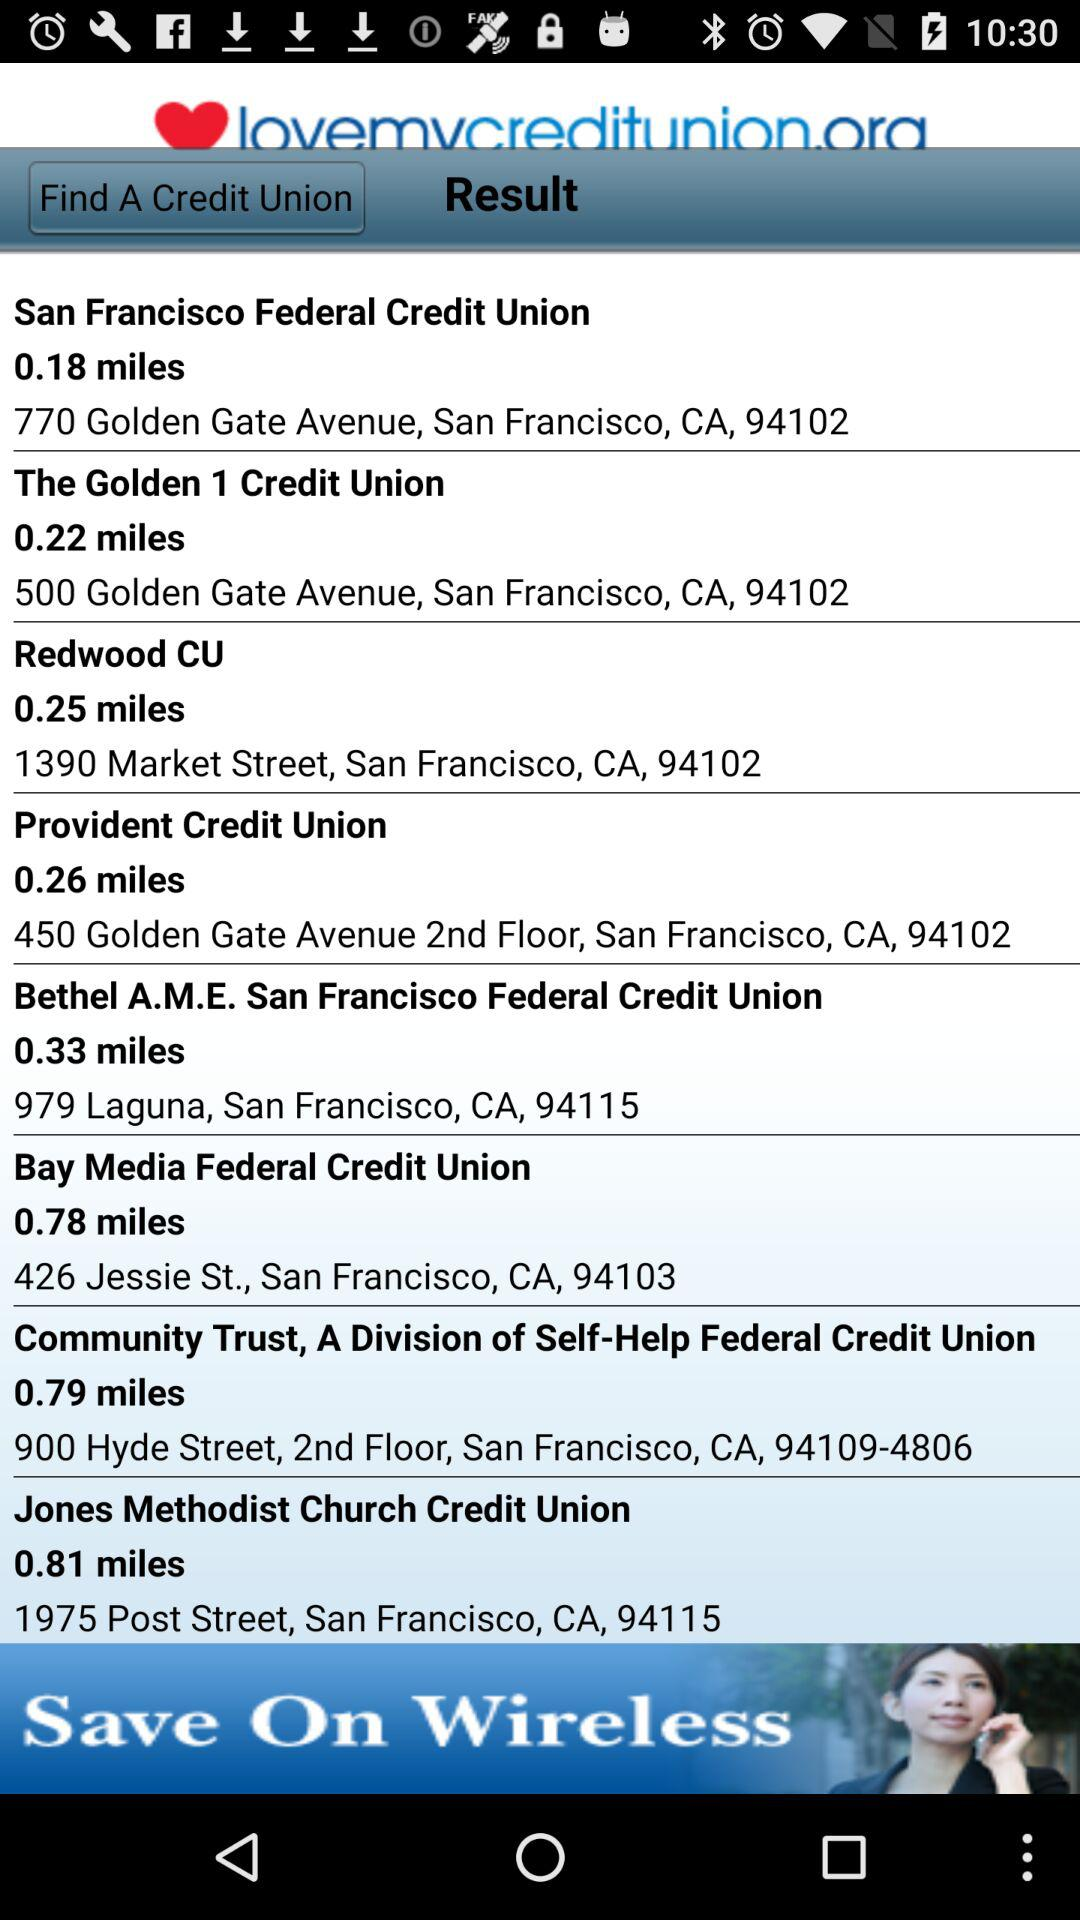How far is "The Golden 1 Credit Union"? "The Golden 1 Credit Union" is 0.22 miles away. 